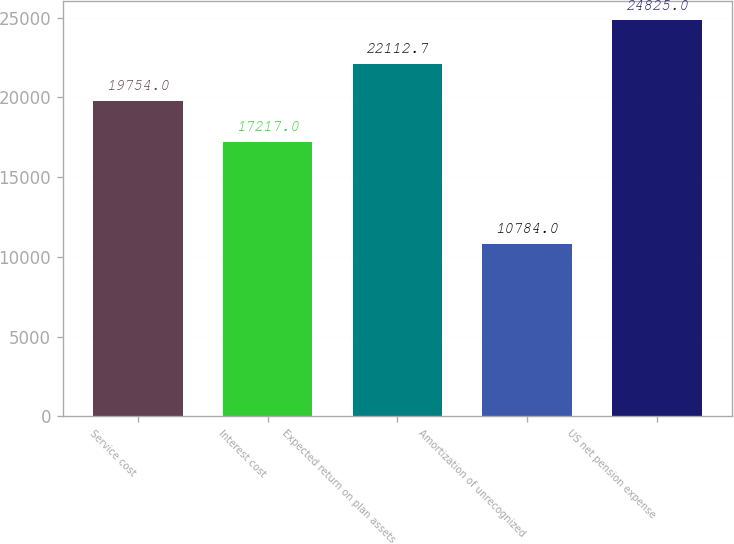Convert chart to OTSL. <chart><loc_0><loc_0><loc_500><loc_500><bar_chart><fcel>Service cost<fcel>Interest cost<fcel>Expected return on plan assets<fcel>Amortization of unrecognized<fcel>US net pension expense<nl><fcel>19754<fcel>17217<fcel>22112.7<fcel>10784<fcel>24825<nl></chart> 